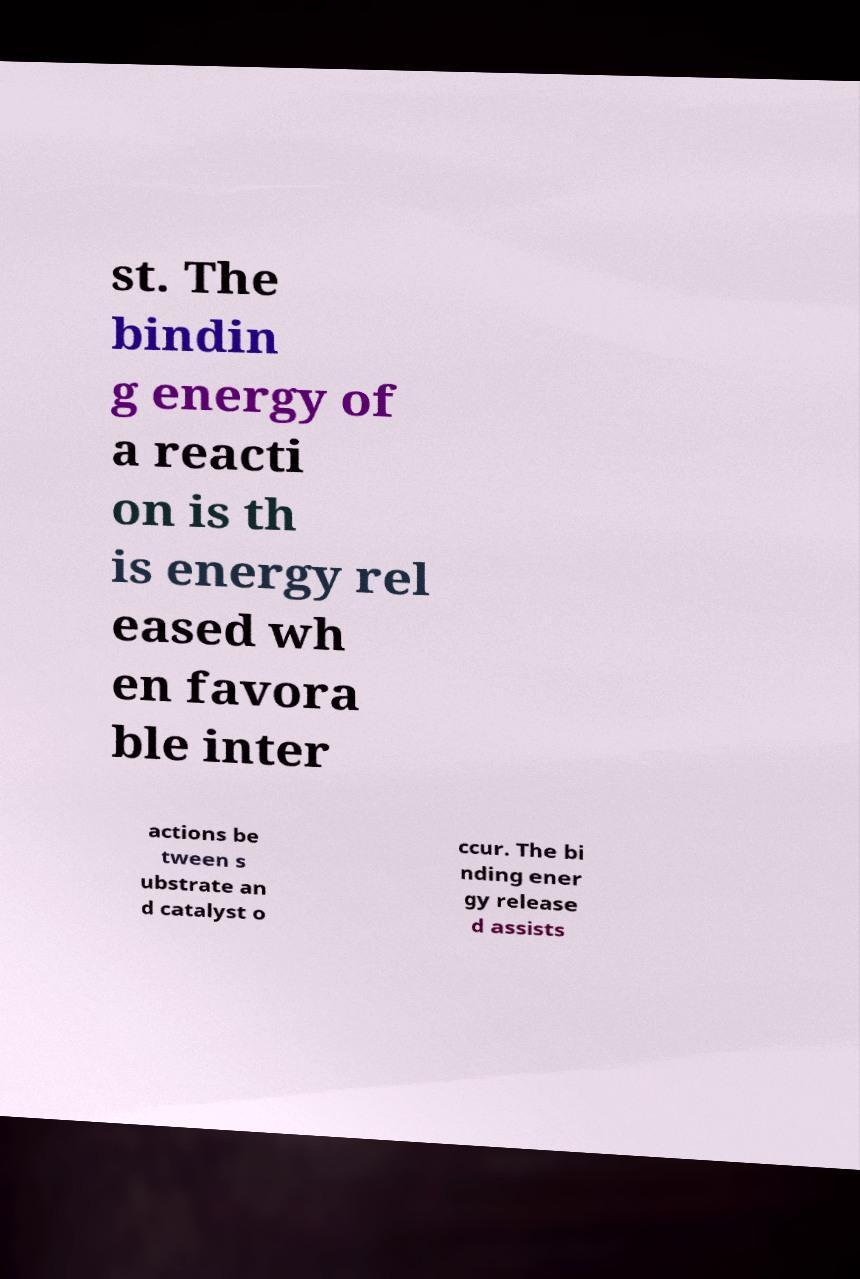There's text embedded in this image that I need extracted. Can you transcribe it verbatim? st. The bindin g energy of a reacti on is th is energy rel eased wh en favora ble inter actions be tween s ubstrate an d catalyst o ccur. The bi nding ener gy release d assists 